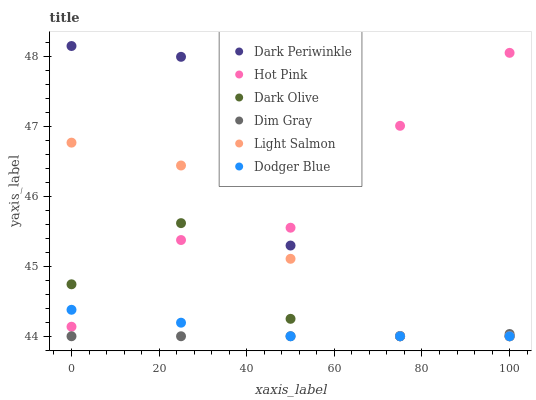Does Dim Gray have the minimum area under the curve?
Answer yes or no. Yes. Does Hot Pink have the maximum area under the curve?
Answer yes or no. Yes. Does Dark Olive have the minimum area under the curve?
Answer yes or no. No. Does Dark Olive have the maximum area under the curve?
Answer yes or no. No. Is Dim Gray the smoothest?
Answer yes or no. Yes. Is Dark Periwinkle the roughest?
Answer yes or no. Yes. Is Dark Olive the smoothest?
Answer yes or no. No. Is Dark Olive the roughest?
Answer yes or no. No. Does Light Salmon have the lowest value?
Answer yes or no. Yes. Does Hot Pink have the lowest value?
Answer yes or no. No. Does Dark Periwinkle have the highest value?
Answer yes or no. Yes. Does Dark Olive have the highest value?
Answer yes or no. No. Is Dim Gray less than Hot Pink?
Answer yes or no. Yes. Is Hot Pink greater than Dim Gray?
Answer yes or no. Yes. Does Dim Gray intersect Dodger Blue?
Answer yes or no. Yes. Is Dim Gray less than Dodger Blue?
Answer yes or no. No. Is Dim Gray greater than Dodger Blue?
Answer yes or no. No. Does Dim Gray intersect Hot Pink?
Answer yes or no. No. 